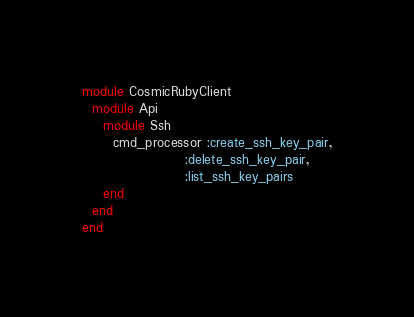Convert code to text. <code><loc_0><loc_0><loc_500><loc_500><_Ruby_>module CosmicRubyClient
  module Api
    module Ssh
      cmd_processor :create_ssh_key_pair,
                    :delete_ssh_key_pair,
                    :list_ssh_key_pairs
    end
  end
end
</code> 